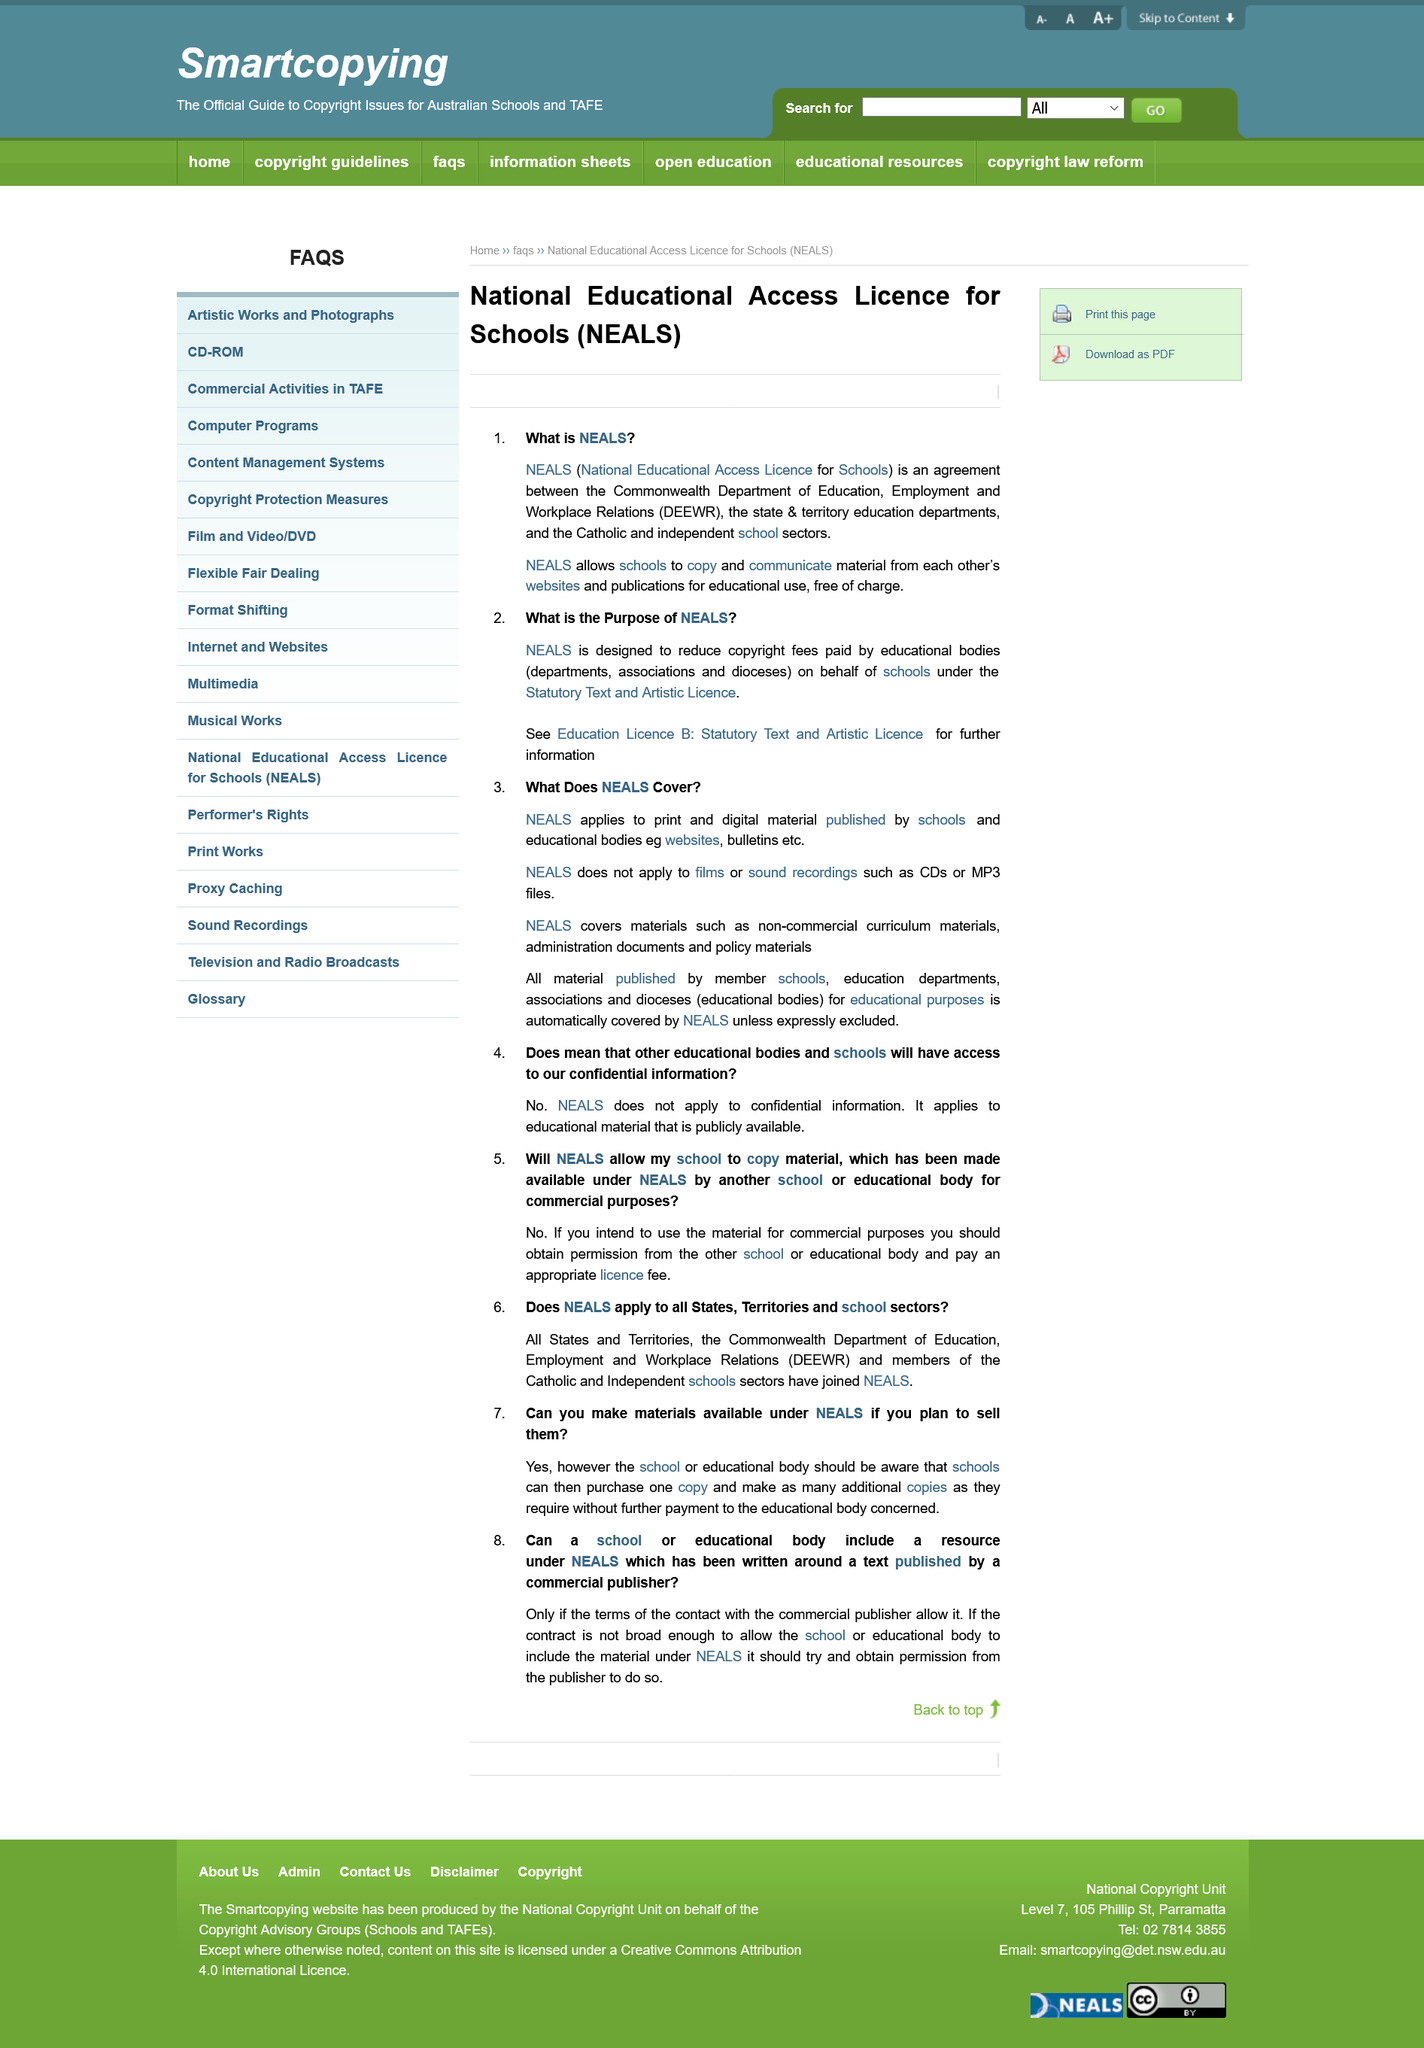Outline some significant characteristics in this image. NEALS stands for the National Educational Access Licence for Schools, which provides access to educational resources for schools. The National Educational Access License for Schools is designed to reduce the fees paid by educational bodies for copyright. It is declared that all material published by a school for educational purposes is automatically covered by the NEALS. The acronym DEEWR stands for the Department of Education, Employment and Workplace Relations, which is responsible for overseeing the education and employment sectors, as well as managing workplace relationships in Australia. NEALS does not cover films. 